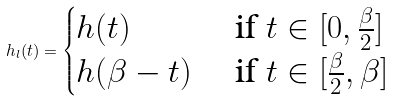Convert formula to latex. <formula><loc_0><loc_0><loc_500><loc_500>h _ { l } ( t ) = \begin{cases} h ( t ) & \text { if $t \in [0, \frac{\beta}{2}]$} \\ h ( \beta - t ) & \text { if $t \in [\frac{\beta}{2}, \beta]$} \end{cases}</formula> 